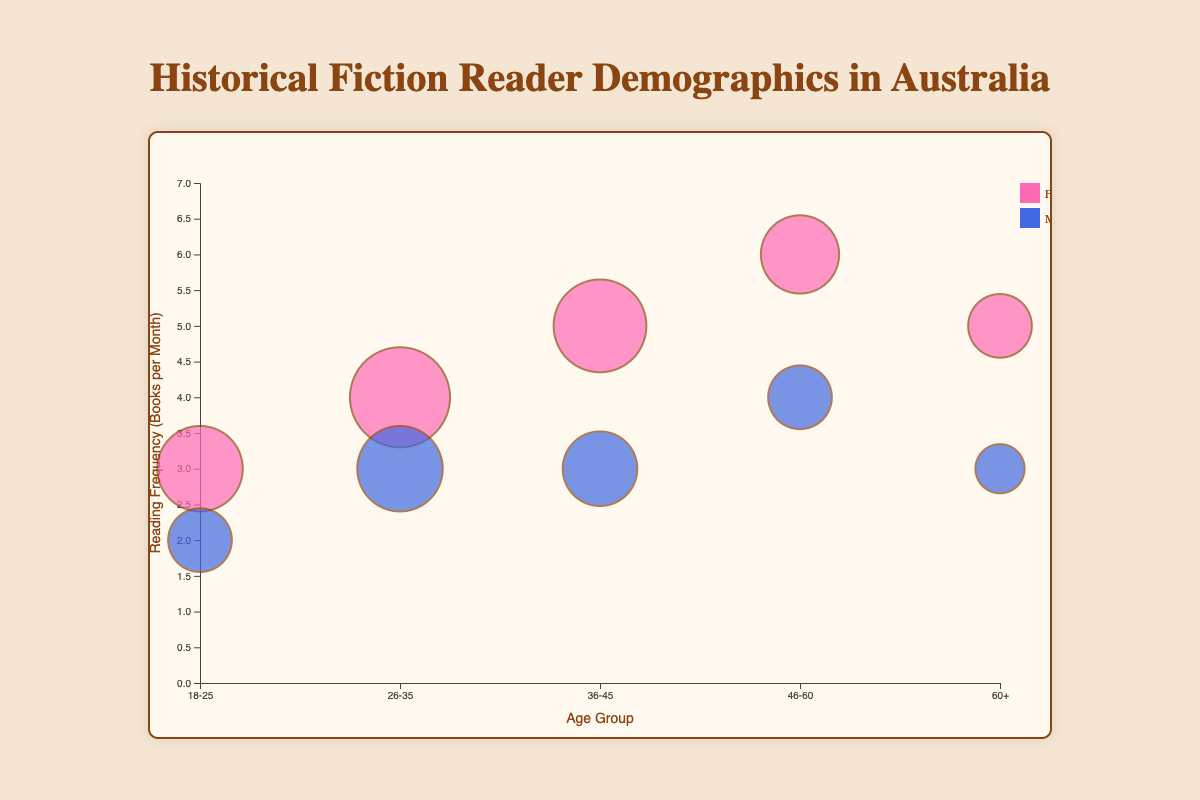What is the title of the chart? The title is written at the top of the chart in large, bold letters. It reads, "Historical Fiction Reader Demographics in Australia".
Answer: Historical Fiction Reader Demographics in Australia What age group has the highest reading frequency for females? Locate the circles representing females on the Y-axis. The highest reading frequency corresponds to the circle at the top of the vertical position. It's from the age group 46-60 with a reading frequency of 6 books per month.
Answer: 46-60 Which gender reads more frequently in the age group 18-25? Compare the position of the male and female bubbles on the Y-axis for the age group 18-25. The circle representing females is higher with a reading frequency of 3 books per month, while the male circle has a frequency of 2.
Answer: Female What is the average reading frequency for males aged 36-45 and 60+? First, identify the reading frequencies for males in the 36-45 and 60+ age groups, which are 3 books/month each. Average these two numbers: (3 + 3) / 2 = 3.
Answer: 3 What is the largest bubble (population percentage) for male readers? Identify the largest circle for males by examining the size (radius) of the circles. The largest bubble belongs to males aged 26-35 with a population percentage of 18%.
Answer: 18% Which age group has the same reading frequency for both genders? Look for age groups where both the male and female circles are at the same Y-axis position. The age group 36-45 has 3 books/month for both genders.
Answer: 36-45 Compare the population percentages of female and male readers in the age group 46-60. Which gender has a higher percentage? Compare the sizes of the bubbles for males and females in the 46-60 age group. The female bubble is larger (16%) than the male bubble (12%).
Answer: Female What is the difference in reading frequency between the age group 26-35 males and 46-60 females? Subtract the reading frequency of males aged 26-35 (3 books/month) from the reading frequency of females aged 46-60 (6 books/month): 6 - 3 = 3.
Answer: 3 How many books do females aged 60+ read per month? Locate the circle for females in the 60+ age group and read its Y-axis position. They read 5 books per month.
Answer: 5 Which gender in the age group 26-35 has a higher reading frequency, and by how much? Compare the Y-axis positions for males and females aged 26-35. Females read 4 books/month while males read 3. The difference is 1 book per month.
Answer: Female, by 1 